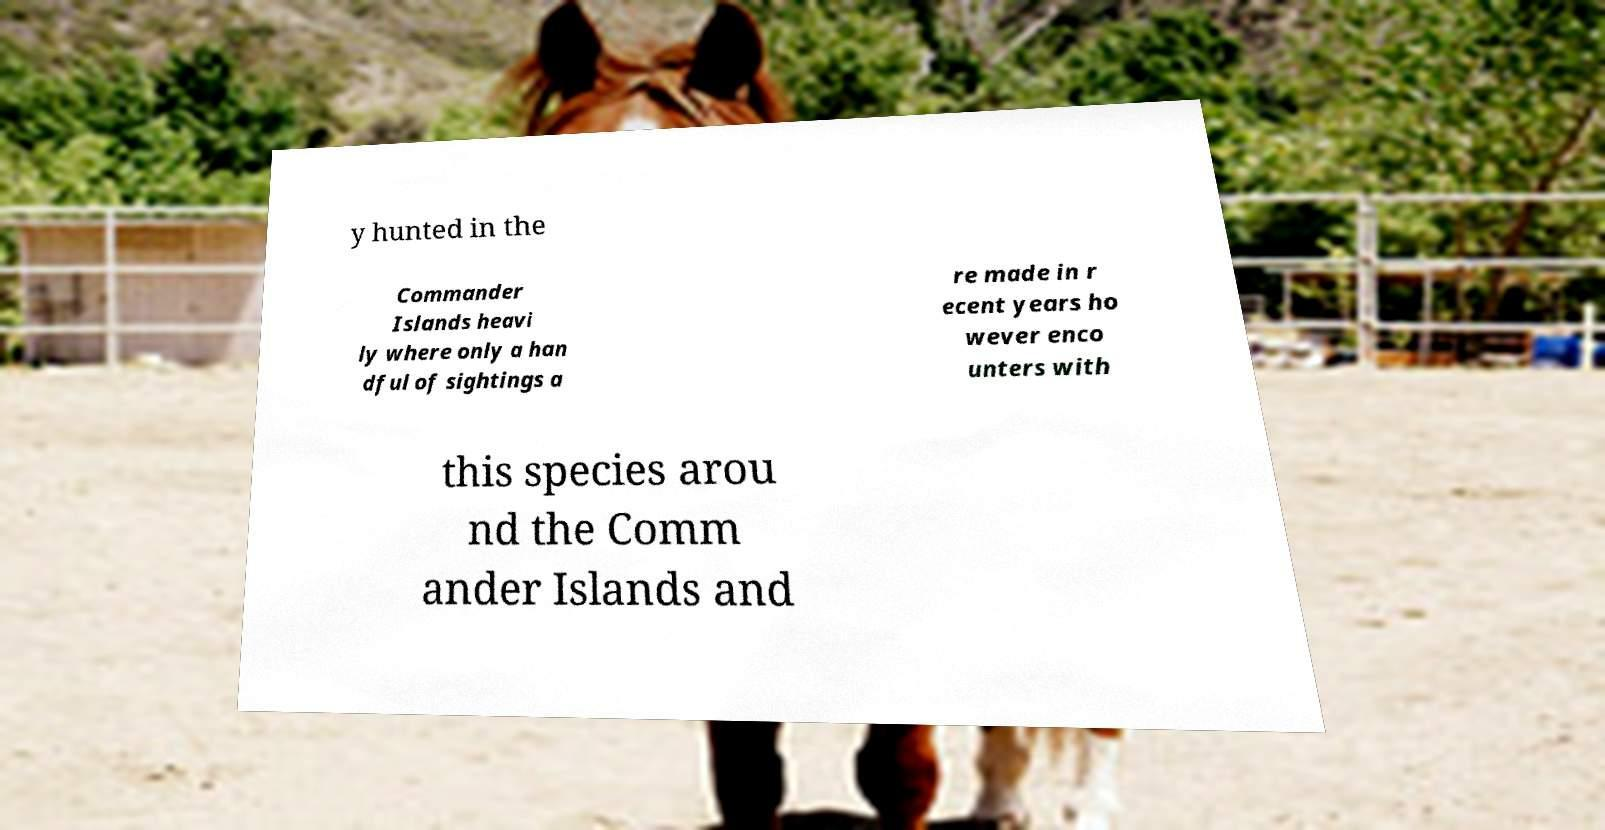Can you read and provide the text displayed in the image?This photo seems to have some interesting text. Can you extract and type it out for me? y hunted in the Commander Islands heavi ly where only a han dful of sightings a re made in r ecent years ho wever enco unters with this species arou nd the Comm ander Islands and 